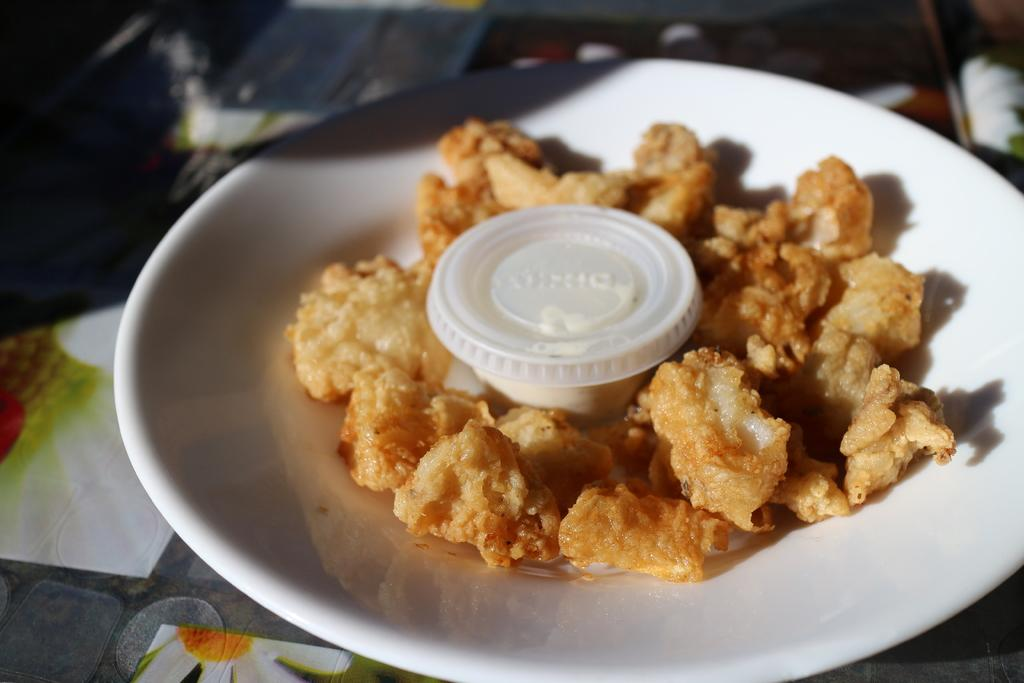What types of food items can be seen in the image? There are food items in the image, but their specific types cannot be determined from the provided facts. What is the color of the cup in the image? The color of the cup in the image cannot be determined from the provided facts. What is the color of the plate in the image? The plate is white. Can you tell me how many cabbages are on the plate in the image? There is no mention of cabbages in the image, so it is impossible to determine their presence or quantity. What is the girl doing in the image? There is no girl present in the image, so it is impossible to describe her actions or activities. 